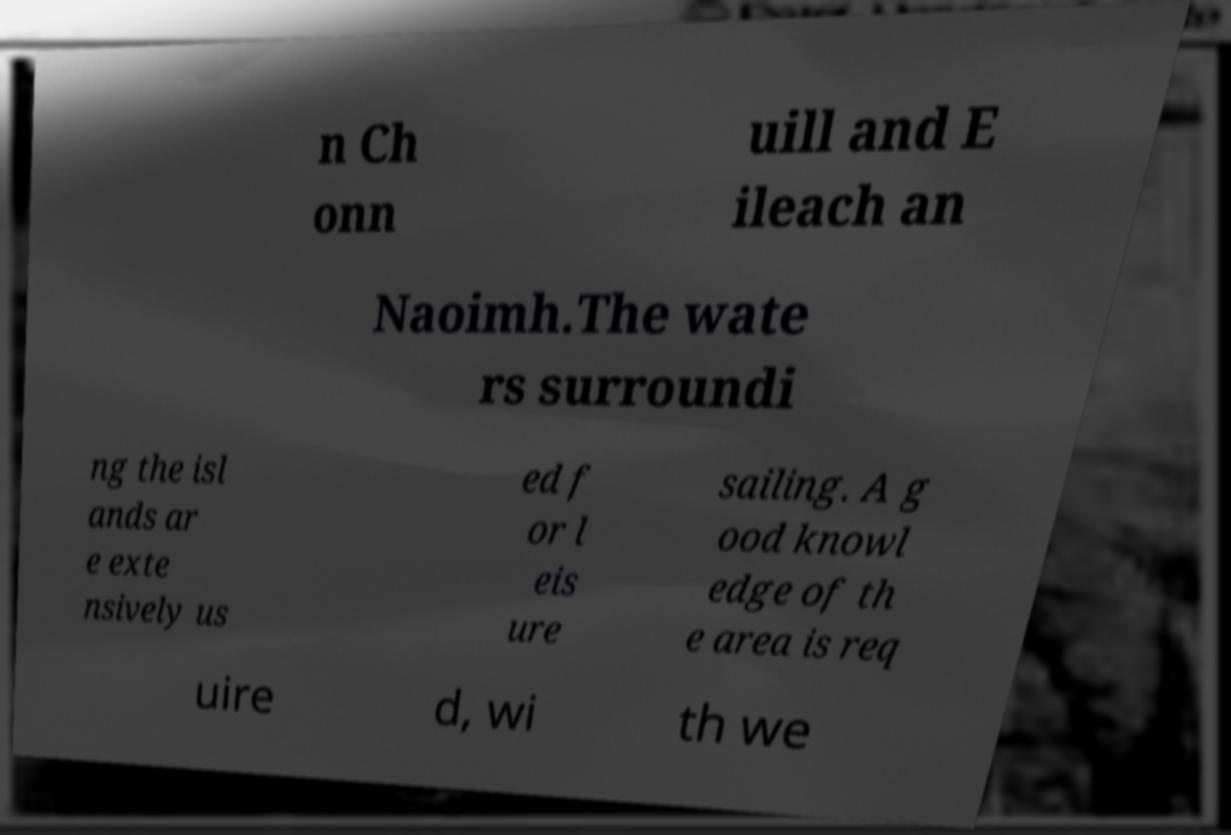For documentation purposes, I need the text within this image transcribed. Could you provide that? n Ch onn uill and E ileach an Naoimh.The wate rs surroundi ng the isl ands ar e exte nsively us ed f or l eis ure sailing. A g ood knowl edge of th e area is req uire d, wi th we 